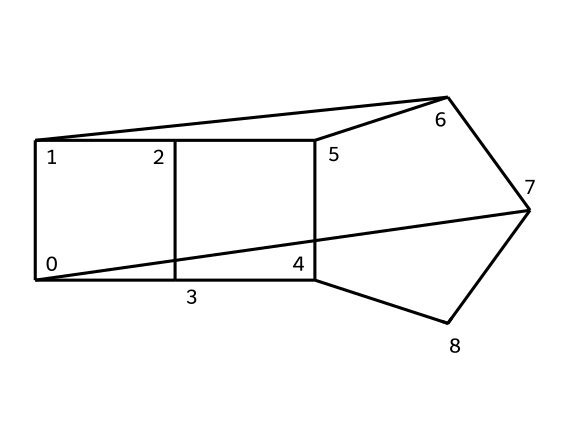What is the molecular formula of adamantane? To determine the molecular formula, we count the number of carbon (C) and hydrogen (H) atoms present in the structure. In adamantane, there are 10 carbon atoms and 16 hydrogen atoms. Thus, the molecular formula is C10H16.
Answer: C10H16 How many carbon atoms are in adamantane? By observing the structure derived from the SMILES notation, we can count the carbon atoms directly. There are a total of 10 distinct carbon atoms in the cage compound adamantane.
Answer: 10 What type of hybridization do the carbon atoms in adamantane exhibit? In adamantane, the carbon atoms are sp3 hybridized, as indicated by the tetrahedral geometry around each carbon atom. This is typical in saturated hydrocarbons.
Answer: sp3 How many hydrogen atoms are bonded to each carbon in adamantane? Adamantane features a structure where each carbon atom is bonded to two hydrogen atoms due to its saturation and bonding configuration. Therefore, most carbon atoms in adamantane have two hydrogen atoms.
Answer: 2 What is the geometric shape of the adamantane molecule? The overall cage structure of adamantane can be categorized as a polyhedral shape, specifically a type of diamond-like configuration. This results from the interconnection of carbon atoms in a 3D cage form.
Answer: cage Which characteristic of cage compounds does adamantane exhibit? Adamantane is unique among cage compounds because it has a three-dimensional, closed-cage structure composed entirely of carbon atoms. This property distinguishes it from other chemical structures.
Answer: closed-cage structure What essential oils contain adamantane? Adamantane can be found in certain essential oils such as those derived from the resin of certain trees, where its presence contributes to the oil's aromatic quality.
Answer: essential oils 